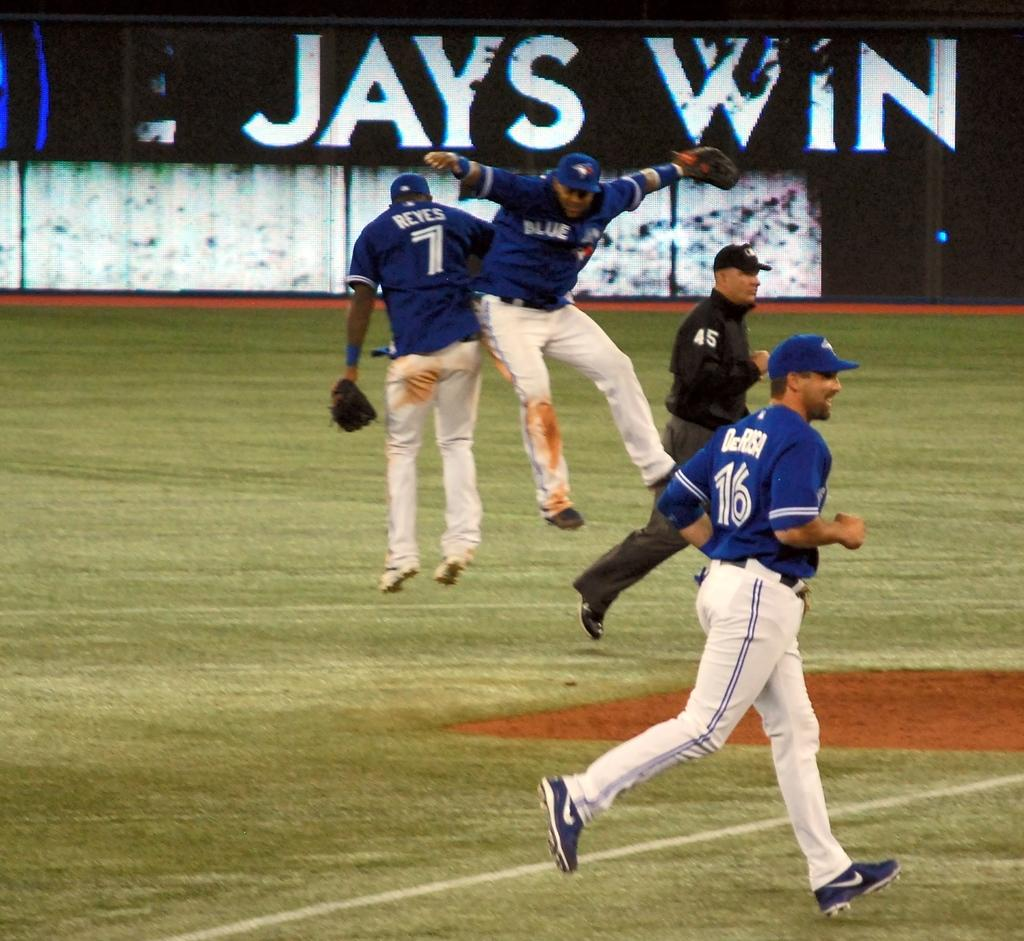<image>
Provide a brief description of the given image. Baseball players jump in front of a sign that says Jays Win. 